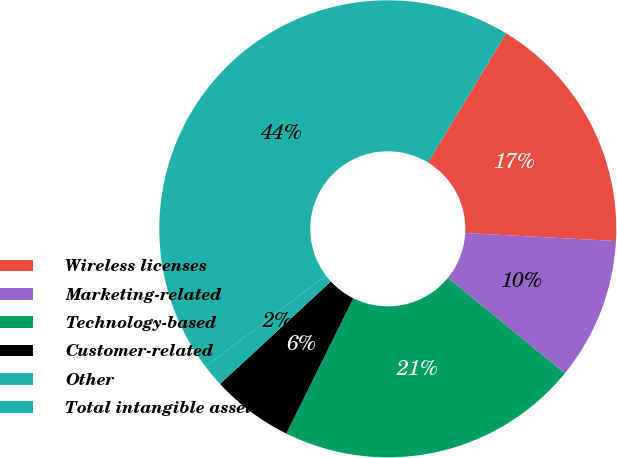Convert chart to OTSL. <chart><loc_0><loc_0><loc_500><loc_500><pie_chart><fcel>Wireless licenses<fcel>Marketing-related<fcel>Technology-based<fcel>Customer-related<fcel>Other<fcel>Total intangible assets<nl><fcel>17.19%<fcel>10.04%<fcel>21.43%<fcel>5.8%<fcel>1.56%<fcel>43.97%<nl></chart> 